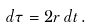<formula> <loc_0><loc_0><loc_500><loc_500>d \tau = 2 r \, d t \, .</formula> 